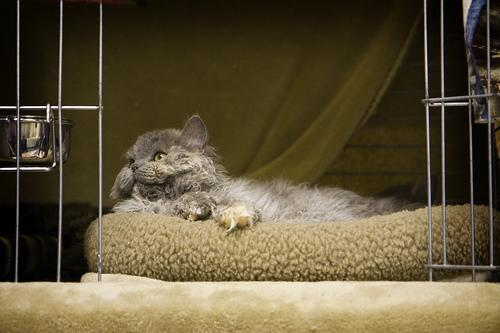What type of animal is in this cage? cat 